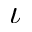Convert formula to latex. <formula><loc_0><loc_0><loc_500><loc_500>\iota</formula> 